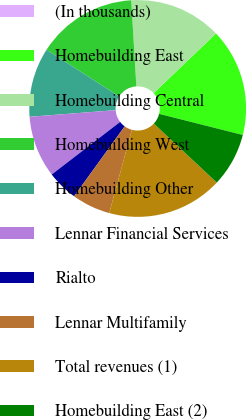<chart> <loc_0><loc_0><loc_500><loc_500><pie_chart><fcel>(In thousands)<fcel>Homebuilding East<fcel>Homebuilding Central<fcel>Homebuilding West<fcel>Homebuilding Other<fcel>Lennar Financial Services<fcel>Rialto<fcel>Lennar Multifamily<fcel>Total revenues (1)<fcel>Homebuilding East (2)<nl><fcel>0.0%<fcel>16.09%<fcel>13.79%<fcel>14.94%<fcel>10.34%<fcel>9.2%<fcel>4.6%<fcel>5.75%<fcel>17.24%<fcel>8.05%<nl></chart> 